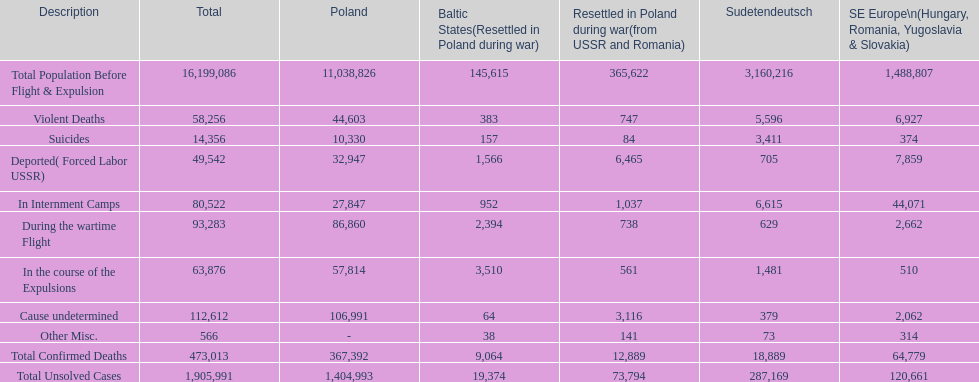In what ways are suicides in poland and sudetendeutsch dissimilar? 6919. 